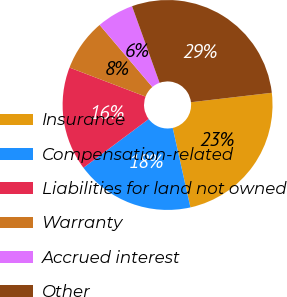Convert chart to OTSL. <chart><loc_0><loc_0><loc_500><loc_500><pie_chart><fcel>Insurance<fcel>Compensation-related<fcel>Liabilities for land not owned<fcel>Warranty<fcel>Accrued interest<fcel>Other<nl><fcel>23.36%<fcel>18.29%<fcel>16.0%<fcel>8.0%<fcel>5.71%<fcel>28.64%<nl></chart> 